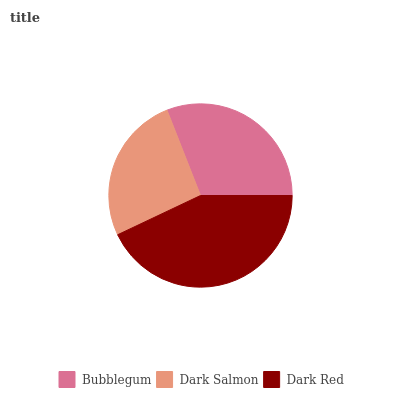Is Dark Salmon the minimum?
Answer yes or no. Yes. Is Dark Red the maximum?
Answer yes or no. Yes. Is Dark Red the minimum?
Answer yes or no. No. Is Dark Salmon the maximum?
Answer yes or no. No. Is Dark Red greater than Dark Salmon?
Answer yes or no. Yes. Is Dark Salmon less than Dark Red?
Answer yes or no. Yes. Is Dark Salmon greater than Dark Red?
Answer yes or no. No. Is Dark Red less than Dark Salmon?
Answer yes or no. No. Is Bubblegum the high median?
Answer yes or no. Yes. Is Bubblegum the low median?
Answer yes or no. Yes. Is Dark Red the high median?
Answer yes or no. No. Is Dark Salmon the low median?
Answer yes or no. No. 